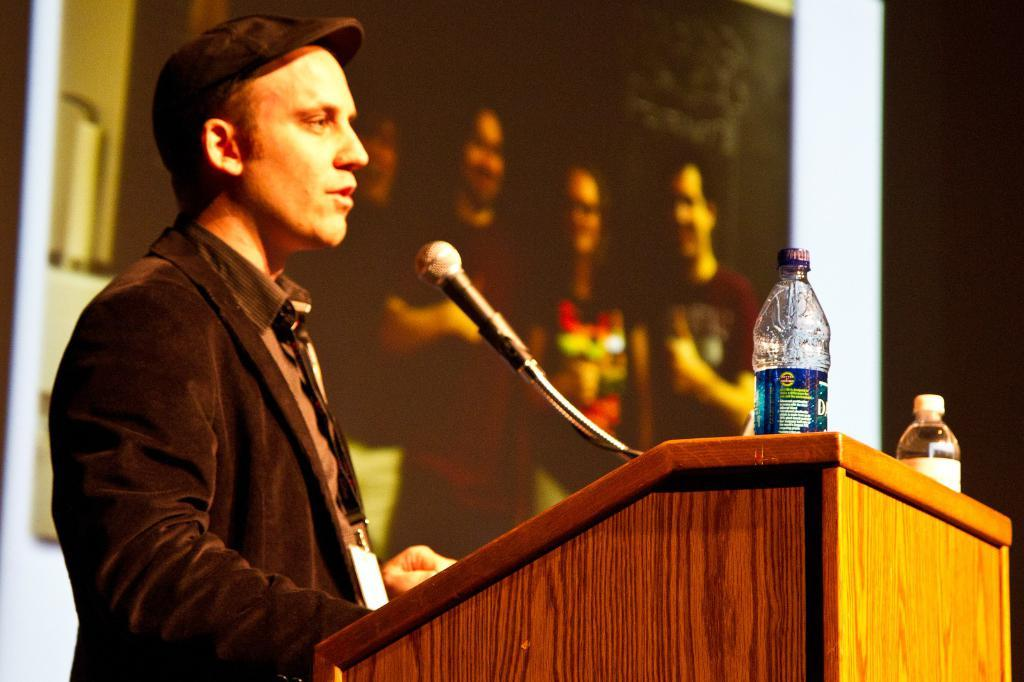Who is present in the image? There is a person in the image. What is the person wearing? The person is wearing a black suit. What is the person standing behind? The person is standing behind a wooden block. What objects are on the wooden block? There is a microphone and water bottles on the wooden block. Where are the pets located in the image? There are no pets present in the image. 